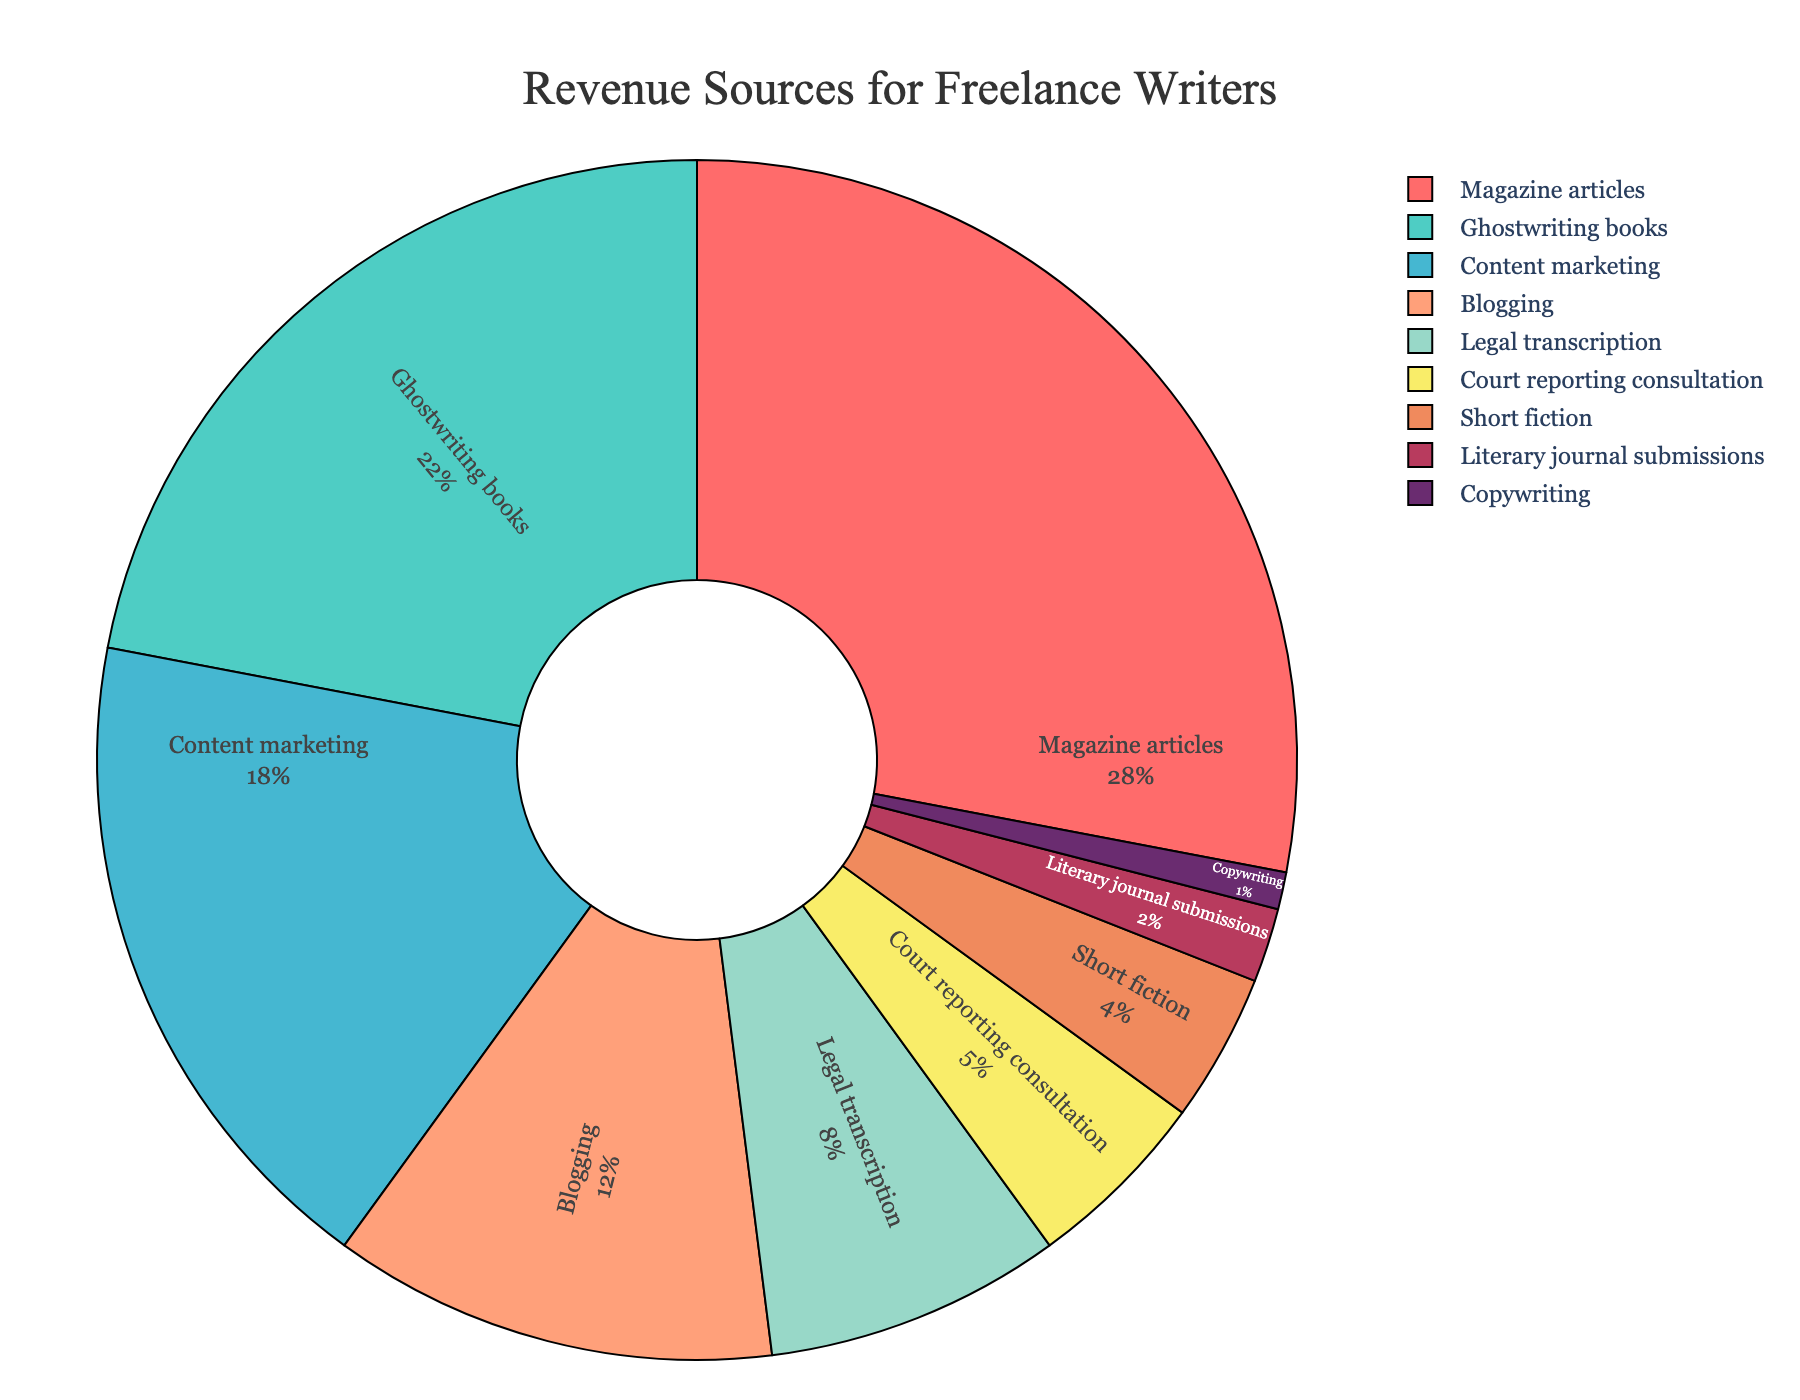What percentage of revenue comes from the three largest sources? The three largest revenue sources are Magazine articles (28%), Ghostwriting books (22%), and Content marketing (18%). Summing these percentages: 28% + 22% + 18% = 68%.
Answer: 68% Which category contributes the least to the revenue? The category with the smallest percentage is Copywriting, contributing 1%.
Answer: Copywriting How much more revenue is generated from Blogging compared to Short fiction? Blogging contributes 12% of the revenue, while Short fiction contributes 4%. The difference is 12% - 4% = 8%.
Answer: 8% If we combine Legal transcription and Court reporting consultation, what is their total contribution to the revenue? Legal transcription contributes 8% and Court reporting consultation contributes 5%. Adding these together: 8% + 5% = 13%.
Answer: 13% Which categories have their contributions displayed in shades of greenish colors, and what are their percentages? The greenish shades in the pie chart are associated with Ghostwriting books and Content marketing, which contribute 22% and 18% respectively.
Answer: Ghostwriting books (22%), Content marketing (18%) What's the total percentage of revenue contributed by all writing categories (Magazine articles, Ghostwriting books, Content marketing, Blogging, and Short fiction)? Summing the percentages for Magazine articles (28%), Ghostwriting books (22%), Content marketing (18%), Blogging (12%), and Short fiction (4%): 28% + 22% + 18% + 12% + 4% = 84%.
Answer: 84% Which writing category generates more revenue: Blogging or Legal transcription? Blogging generates 12% of the revenue, while Legal transcription generates 8%. Therefore, Blogging generates more revenue.
Answer: Blogging Among Literary journal submissions and Copywriting, which one has a higher contribution to the revenue? Literary journal submissions contribute 2%, while Copywriting contributes 1%. Therefore, Literary journal submissions have a higher contribution.
Answer: Literary journal submissions What is the average percentage of the revenue contributed by Magazine articles, Ghostwriting books, and Content marketing? The percentages are Magazine articles (28%), Ghostwriting books (22%), and Content marketing (18%). The average is calculated as (28% + 22% + 18%) / 3 = 68% / 3 ≈ 22.67%.
Answer: 22.67% Which colored section represents Ghostwriting books, and how much does it contribute to the revenue? Ghostwriting books is represented by the greenish section and contributes 22% to the revenue.
Answer: Greenish, 22% 